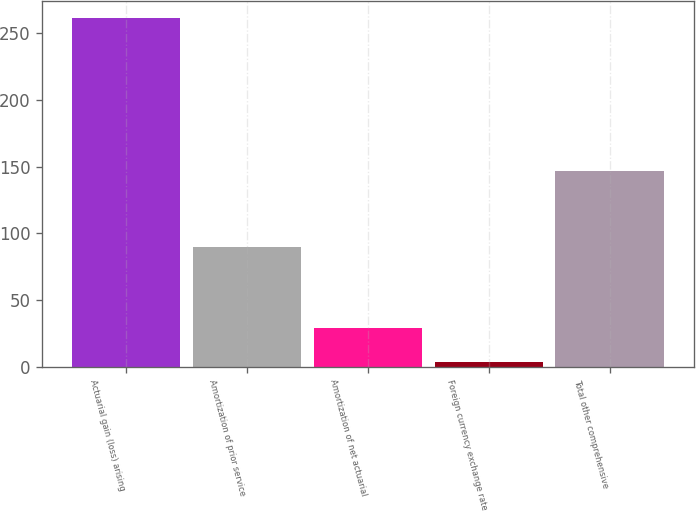Convert chart to OTSL. <chart><loc_0><loc_0><loc_500><loc_500><bar_chart><fcel>Actuarial gain (loss) arising<fcel>Amortization of prior service<fcel>Amortization of net actuarial<fcel>Foreign currency exchange rate<fcel>Total other comprehensive<nl><fcel>261.3<fcel>90<fcel>29.1<fcel>3.3<fcel>146.7<nl></chart> 